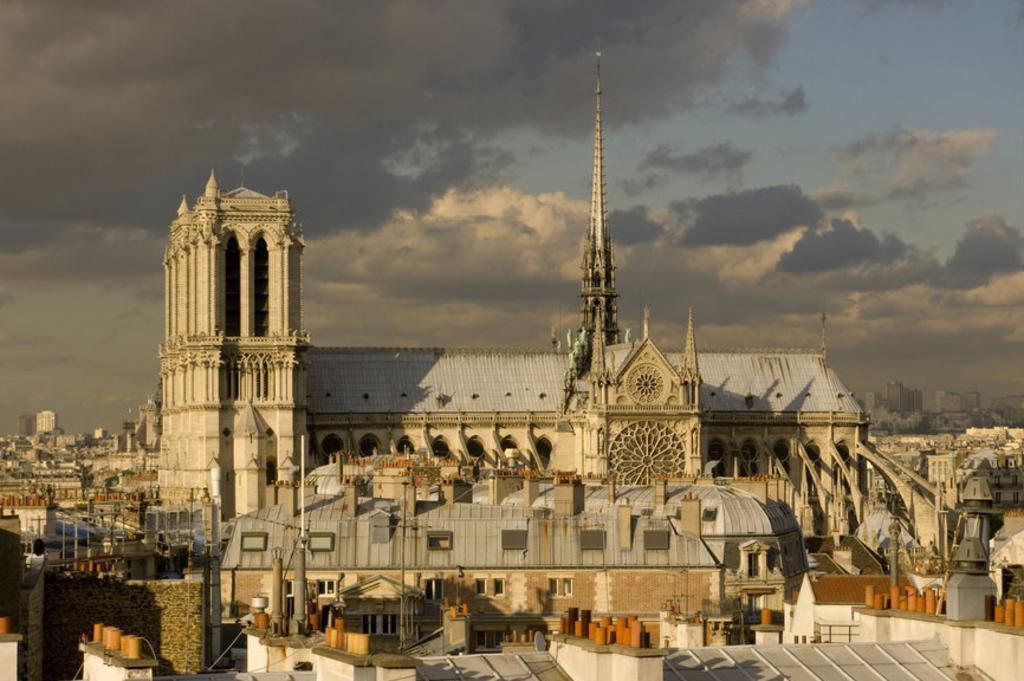Could you give a brief overview of what you see in this image? In this picture we can see few buildings, in the background we can find clouds. 